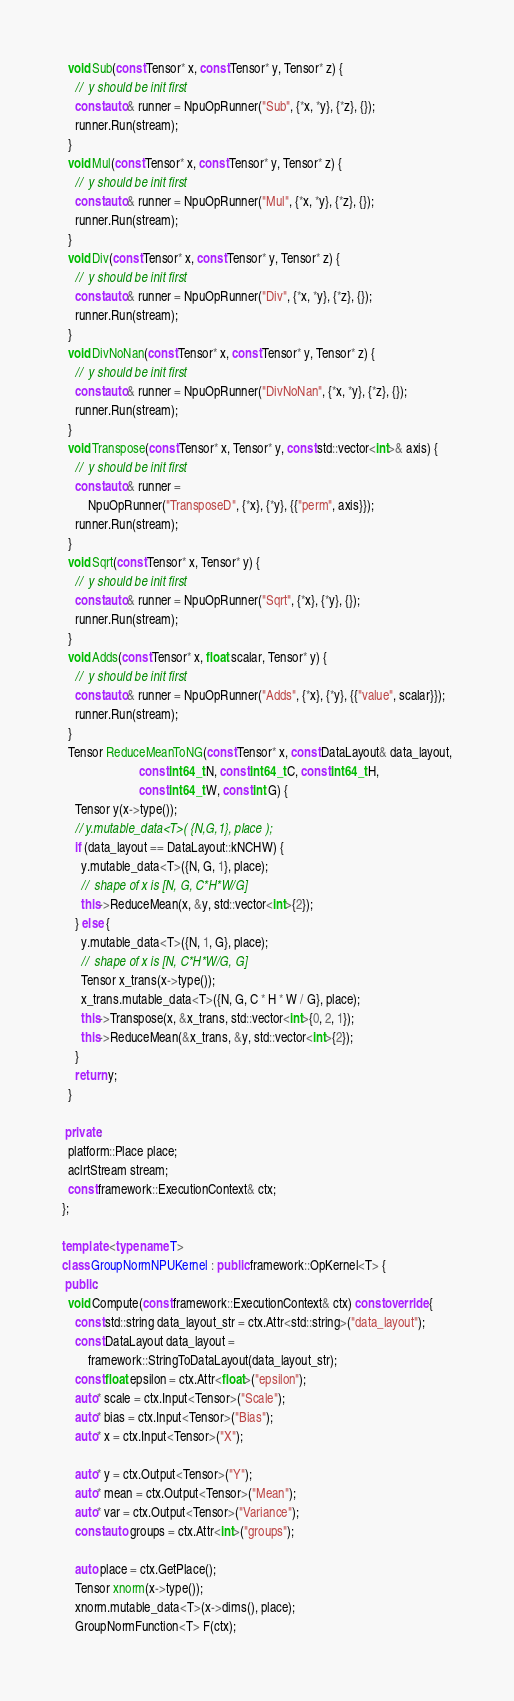Convert code to text. <code><loc_0><loc_0><loc_500><loc_500><_C++_>  void Sub(const Tensor* x, const Tensor* y, Tensor* z) {
    //  y should be init first
    const auto& runner = NpuOpRunner("Sub", {*x, *y}, {*z}, {});
    runner.Run(stream);
  }
  void Mul(const Tensor* x, const Tensor* y, Tensor* z) {
    //  y should be init first
    const auto& runner = NpuOpRunner("Mul", {*x, *y}, {*z}, {});
    runner.Run(stream);
  }
  void Div(const Tensor* x, const Tensor* y, Tensor* z) {
    //  y should be init first
    const auto& runner = NpuOpRunner("Div", {*x, *y}, {*z}, {});
    runner.Run(stream);
  }
  void DivNoNan(const Tensor* x, const Tensor* y, Tensor* z) {
    //  y should be init first
    const auto& runner = NpuOpRunner("DivNoNan", {*x, *y}, {*z}, {});
    runner.Run(stream);
  }
  void Transpose(const Tensor* x, Tensor* y, const std::vector<int>& axis) {
    //  y should be init first
    const auto& runner =
        NpuOpRunner("TransposeD", {*x}, {*y}, {{"perm", axis}});
    runner.Run(stream);
  }
  void Sqrt(const Tensor* x, Tensor* y) {
    //  y should be init first
    const auto& runner = NpuOpRunner("Sqrt", {*x}, {*y}, {});
    runner.Run(stream);
  }
  void Adds(const Tensor* x, float scalar, Tensor* y) {
    //  y should be init first
    const auto& runner = NpuOpRunner("Adds", {*x}, {*y}, {{"value", scalar}});
    runner.Run(stream);
  }
  Tensor ReduceMeanToNG(const Tensor* x, const DataLayout& data_layout,
                        const int64_t N, const int64_t C, const int64_t H,
                        const int64_t W, const int G) {
    Tensor y(x->type());
    // y.mutable_data<T>( {N,G,1}, place );
    if (data_layout == DataLayout::kNCHW) {
      y.mutable_data<T>({N, G, 1}, place);
      //  shape of x is [N, G, C*H*W/G]
      this->ReduceMean(x, &y, std::vector<int>{2});
    } else {
      y.mutable_data<T>({N, 1, G}, place);
      //  shape of x is [N, C*H*W/G, G]
      Tensor x_trans(x->type());
      x_trans.mutable_data<T>({N, G, C * H * W / G}, place);
      this->Transpose(x, &x_trans, std::vector<int>{0, 2, 1});
      this->ReduceMean(&x_trans, &y, std::vector<int>{2});
    }
    return y;
  }

 private:
  platform::Place place;
  aclrtStream stream;
  const framework::ExecutionContext& ctx;
};

template <typename T>
class GroupNormNPUKernel : public framework::OpKernel<T> {
 public:
  void Compute(const framework::ExecutionContext& ctx) const override {
    const std::string data_layout_str = ctx.Attr<std::string>("data_layout");
    const DataLayout data_layout =
        framework::StringToDataLayout(data_layout_str);
    const float epsilon = ctx.Attr<float>("epsilon");
    auto* scale = ctx.Input<Tensor>("Scale");
    auto* bias = ctx.Input<Tensor>("Bias");
    auto* x = ctx.Input<Tensor>("X");

    auto* y = ctx.Output<Tensor>("Y");
    auto* mean = ctx.Output<Tensor>("Mean");
    auto* var = ctx.Output<Tensor>("Variance");
    const auto groups = ctx.Attr<int>("groups");

    auto place = ctx.GetPlace();
    Tensor xnorm(x->type());
    xnorm.mutable_data<T>(x->dims(), place);
    GroupNormFunction<T> F(ctx);</code> 